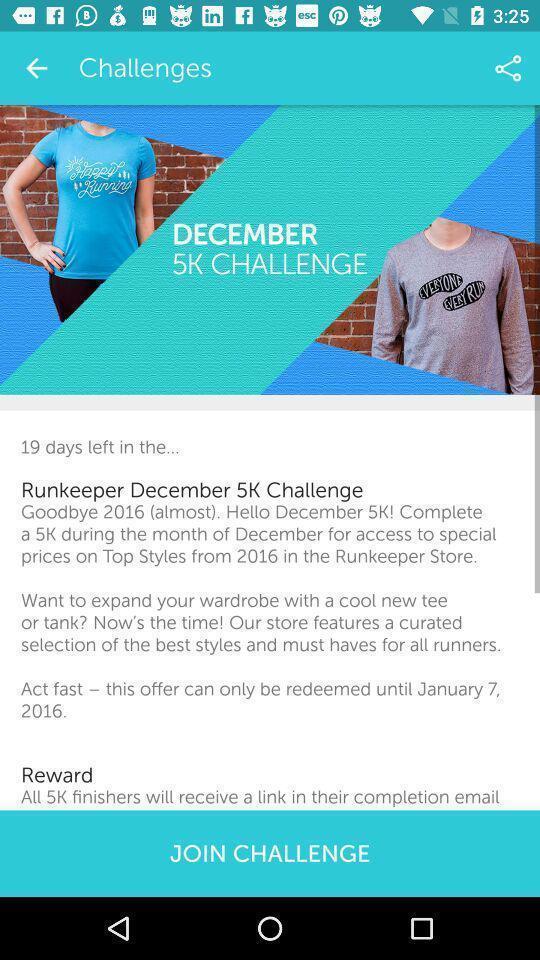What can you discern from this picture? Page displays to join challenge in work out app. 